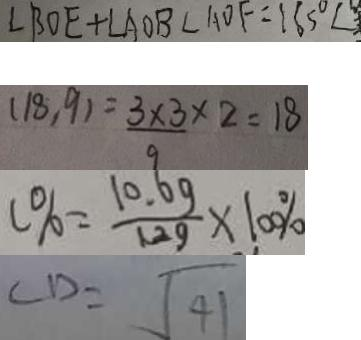Convert formula to latex. <formula><loc_0><loc_0><loc_500><loc_500>\angle B O E + \angle A O B \angle A O F = 1 8 5 ^ { \circ } \angle 
 ( 1 8 , 9 ) = \frac { 3 \times 3 } { 9 } \times 2 = 1 8 
 c \% = \frac { 1 0 . 6 g } { 1 2 g } \times 1 0 0 \% 
 C D = \sqrt { 4 1 }</formula> 